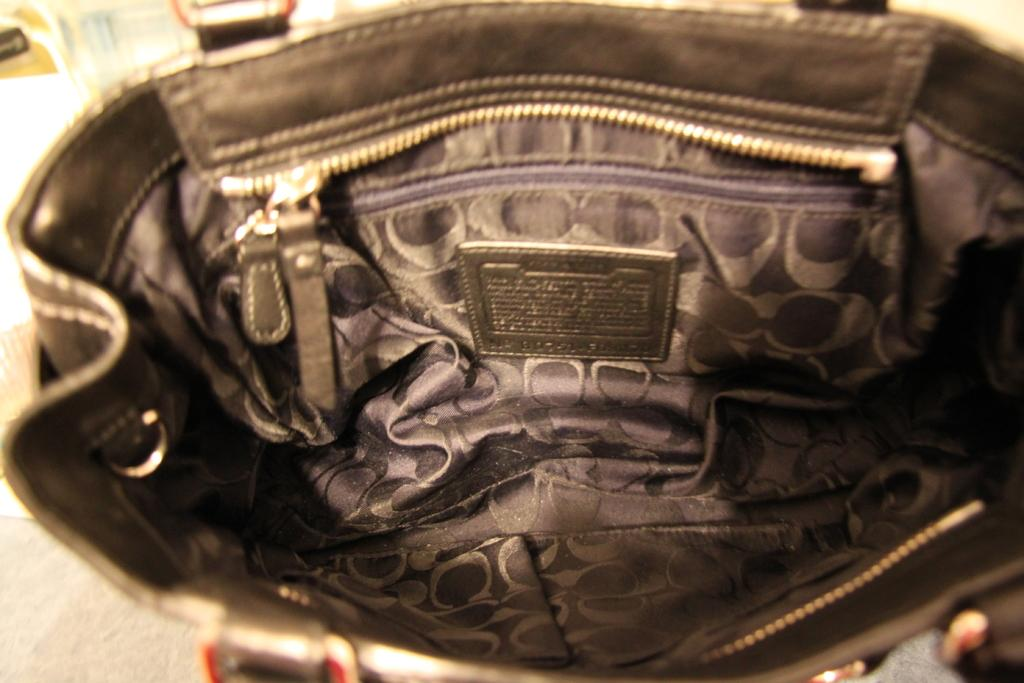What type of view is shown in the image? The image is an inside view of a handbag. Are there any corn kernels visible inside the handbag? There is no corn present in the image, as it is an inside view of a handbag. 